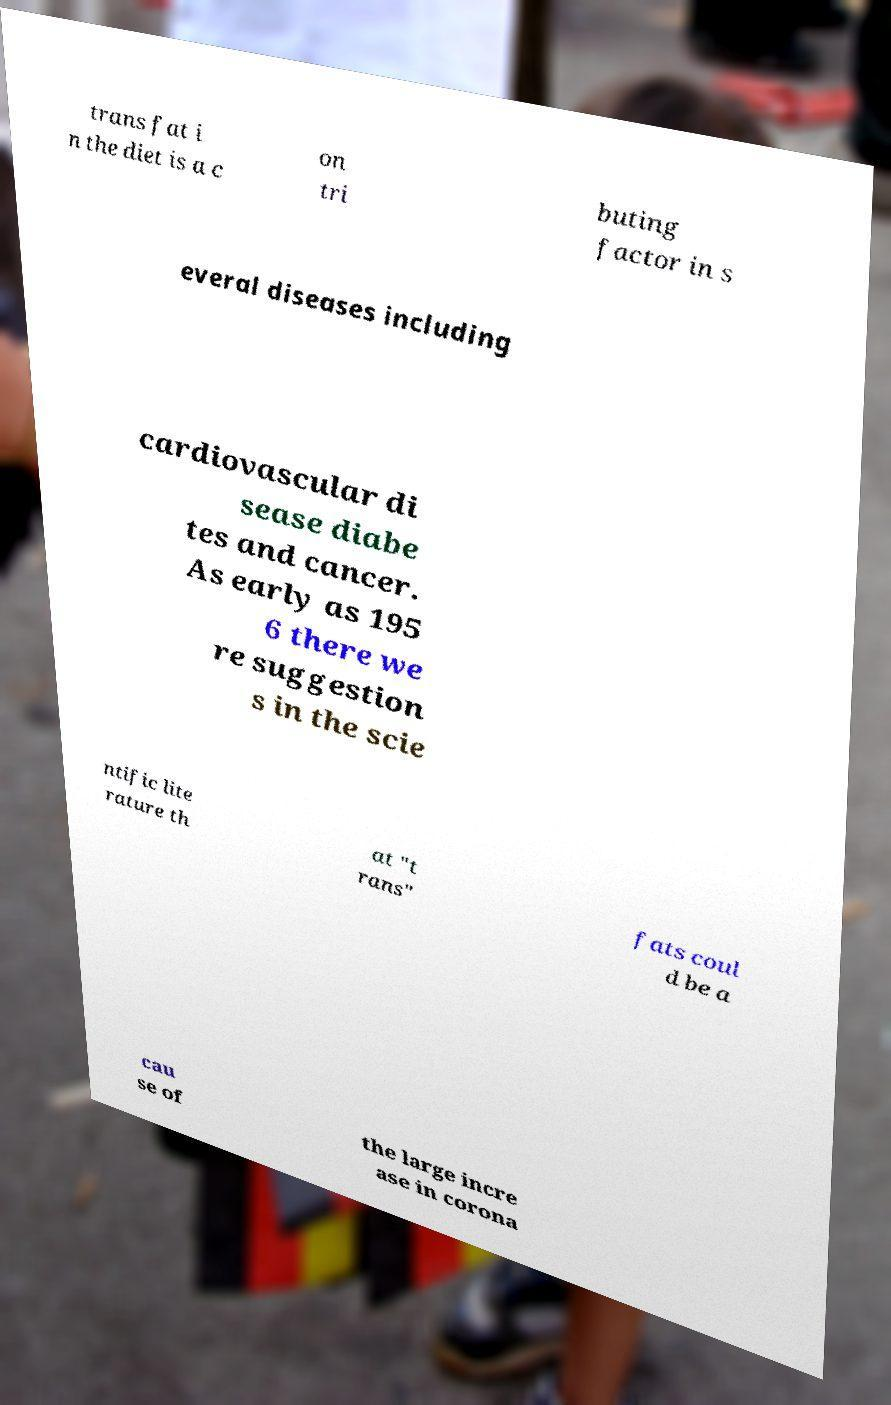Can you read and provide the text displayed in the image?This photo seems to have some interesting text. Can you extract and type it out for me? trans fat i n the diet is a c on tri buting factor in s everal diseases including cardiovascular di sease diabe tes and cancer. As early as 195 6 there we re suggestion s in the scie ntific lite rature th at "t rans" fats coul d be a cau se of the large incre ase in corona 